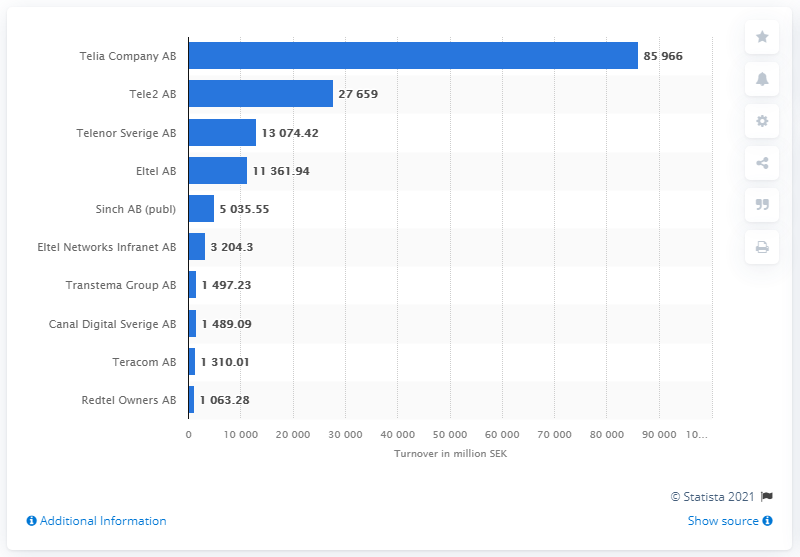Highlight a few significant elements in this photo. Tele2's revenue as of June 2021 was 27,659. As of June 2021, the revenue of Telia Company AB in Swedish kronor was 859,668. 